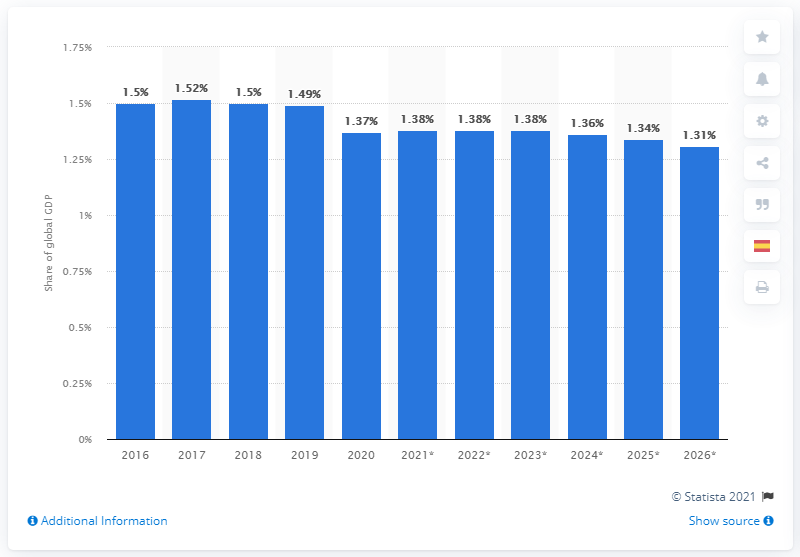List a handful of essential elements in this visual. Spain's share of the global Gross Domestic Product (GDP) in 2020 was 1.36%. 